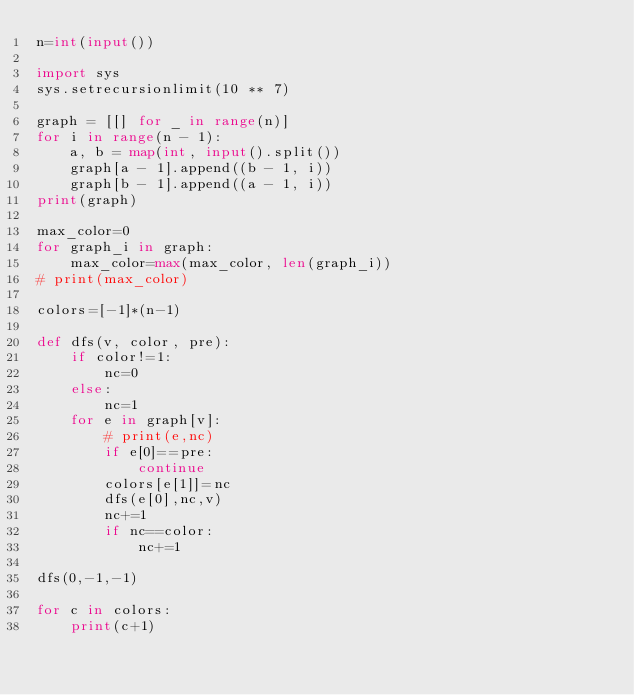<code> <loc_0><loc_0><loc_500><loc_500><_Python_>n=int(input())

import sys
sys.setrecursionlimit(10 ** 7)

graph = [[] for _ in range(n)]
for i in range(n - 1):
    a, b = map(int, input().split())
    graph[a - 1].append((b - 1, i))
    graph[b - 1].append((a - 1, i))
print(graph)

max_color=0
for graph_i in graph:
    max_color=max(max_color, len(graph_i))
# print(max_color)

colors=[-1]*(n-1)

def dfs(v, color, pre):
    if color!=1:
        nc=0
    else:
        nc=1
    for e in graph[v]:
        # print(e,nc)
        if e[0]==pre:
            continue
        colors[e[1]]=nc
        dfs(e[0],nc,v)
        nc+=1
        if nc==color:
            nc+=1

dfs(0,-1,-1)

for c in colors:
    print(c+1)
</code> 